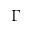Convert formula to latex. <formula><loc_0><loc_0><loc_500><loc_500>\Gamma</formula> 